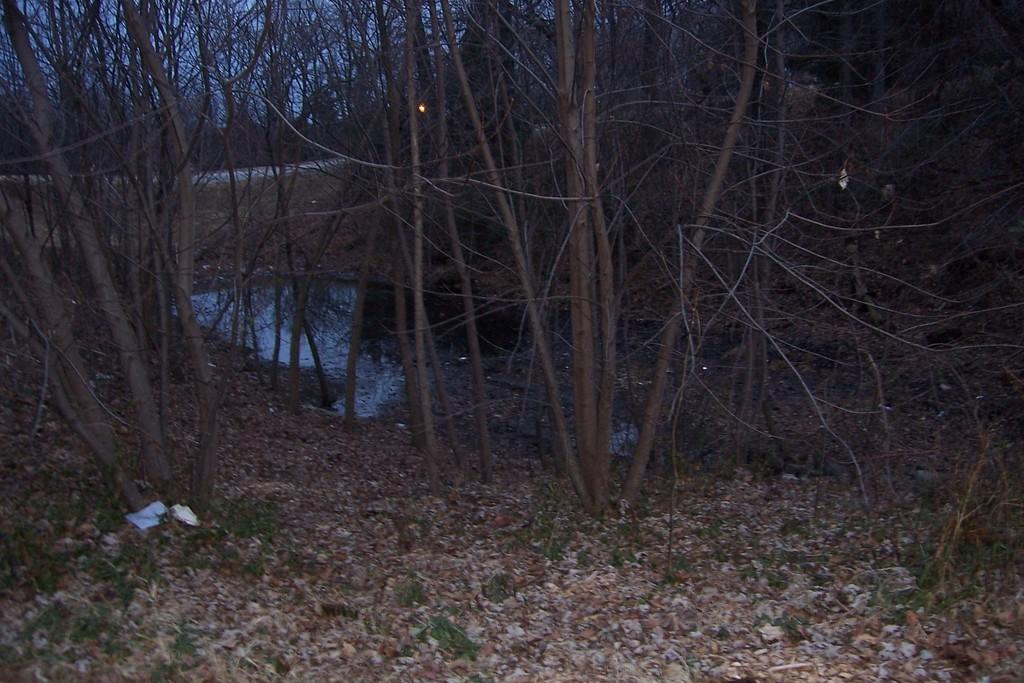What type of vegetation can be seen in the image? There are trees in the image. What type of ground cover is present in the image? There is grass in the image. What type of natural feature can be seen in the image? There are rocks in the image. What type of artificial light source is present in the image? There is a light in the image. What type of body of water is present in the image? There is a lake in the image. What is visible in the sky in the image? The sky is visible in the image. How many zebras are grazing in the grass in the image? There are no zebras present in the image; it features trees, grass, rocks, a light, a lake, and the sky. What type of container is used to collect water from the lake in the image? There is no container present in the image for collecting water from the lake. 